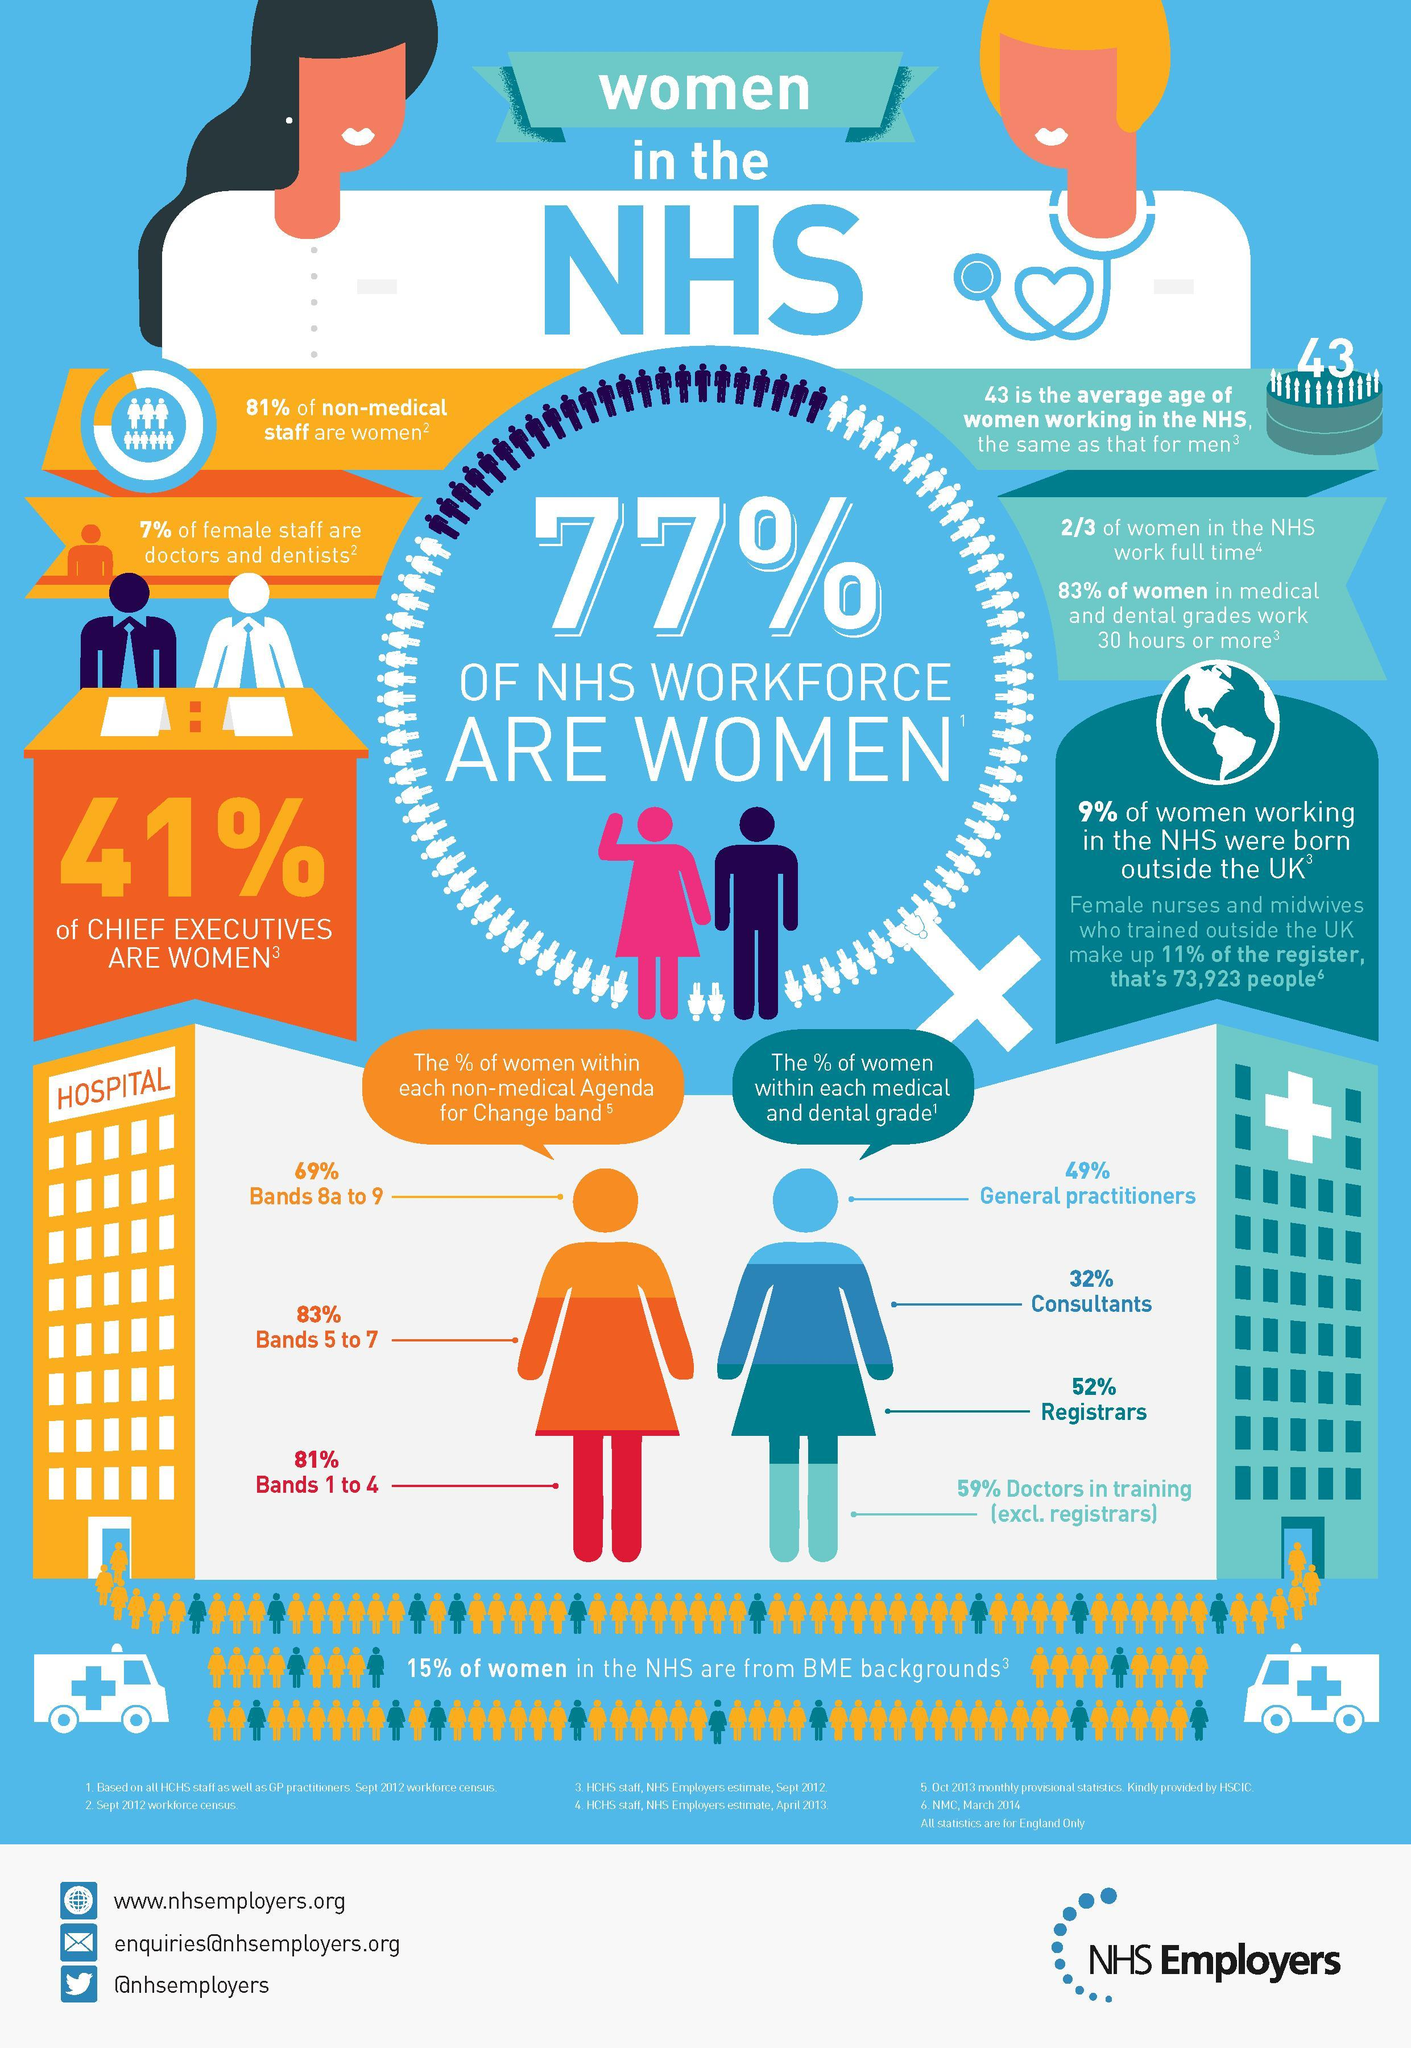What percentage of women in the NHS work full time?
Answer the question with a short phrase. 66.67% What is the average age of men working in the NHS? 43 